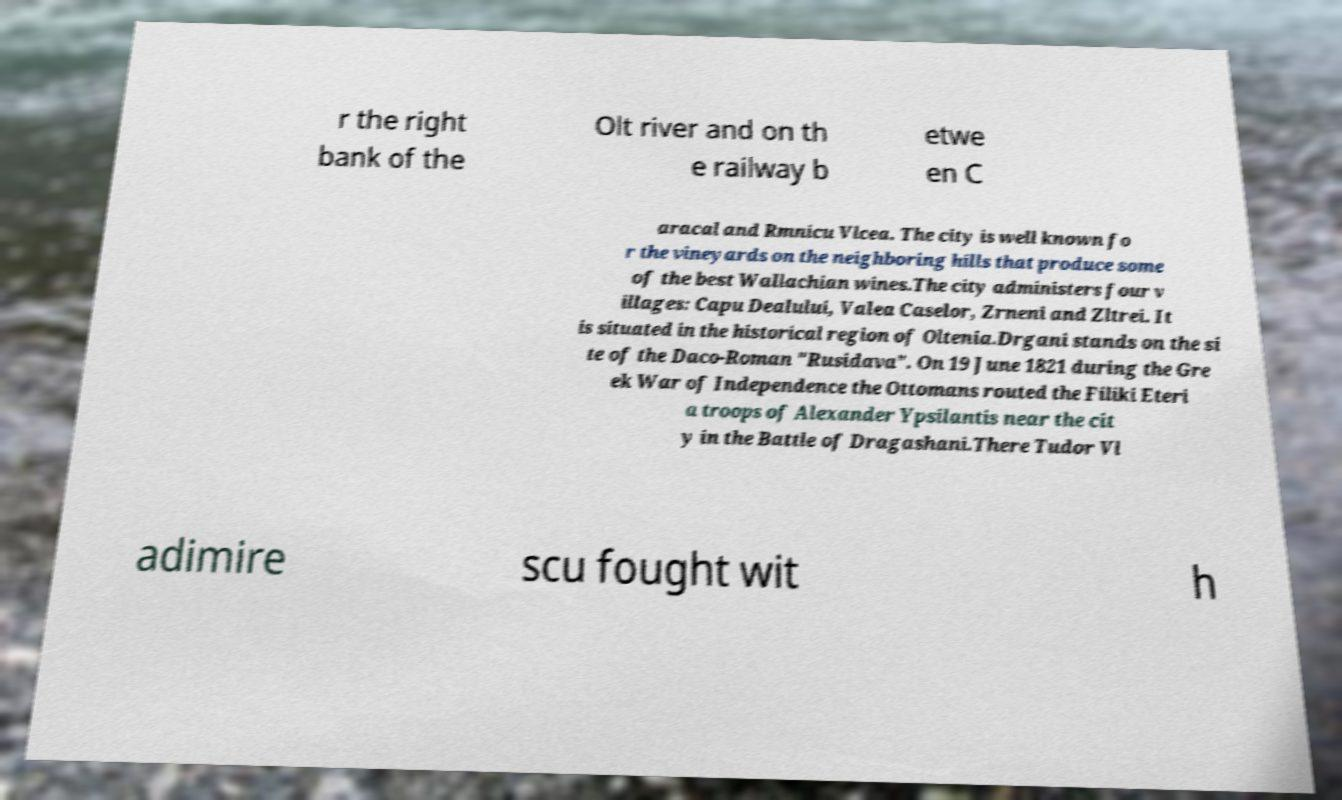Please identify and transcribe the text found in this image. r the right bank of the Olt river and on th e railway b etwe en C aracal and Rmnicu Vlcea. The city is well known fo r the vineyards on the neighboring hills that produce some of the best Wallachian wines.The city administers four v illages: Capu Dealului, Valea Caselor, Zrneni and Zltrei. It is situated in the historical region of Oltenia.Drgani stands on the si te of the Daco-Roman "Rusidava". On 19 June 1821 during the Gre ek War of Independence the Ottomans routed the Filiki Eteri a troops of Alexander Ypsilantis near the cit y in the Battle of Dragashani.There Tudor Vl adimire scu fought wit h 